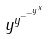Convert formula to latex. <formula><loc_0><loc_0><loc_500><loc_500>y ^ { y ^ { - ^ { - ^ { y ^ { x } } } } }</formula> 